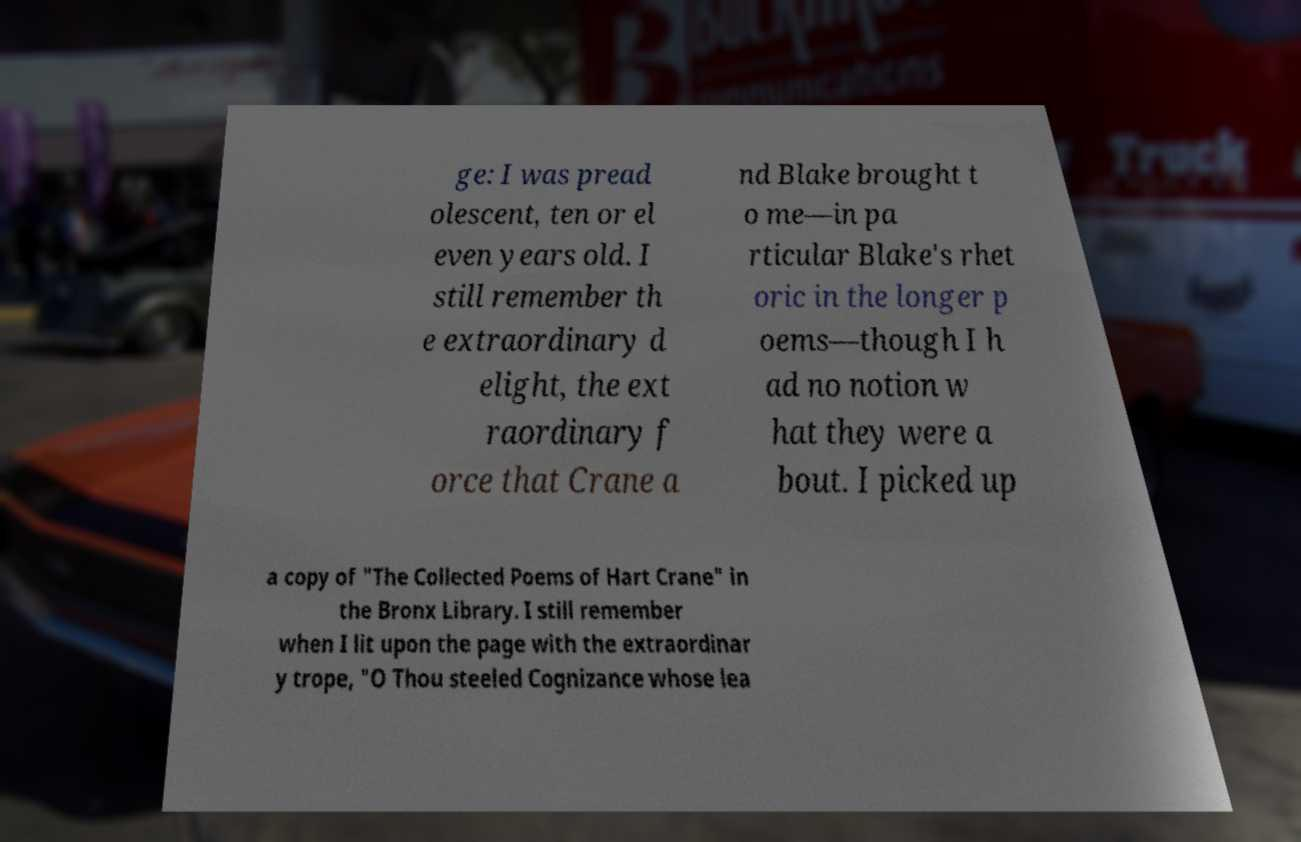Can you accurately transcribe the text from the provided image for me? ge: I was pread olescent, ten or el even years old. I still remember th e extraordinary d elight, the ext raordinary f orce that Crane a nd Blake brought t o me—in pa rticular Blake's rhet oric in the longer p oems—though I h ad no notion w hat they were a bout. I picked up a copy of "The Collected Poems of Hart Crane" in the Bronx Library. I still remember when I lit upon the page with the extraordinar y trope, "O Thou steeled Cognizance whose lea 